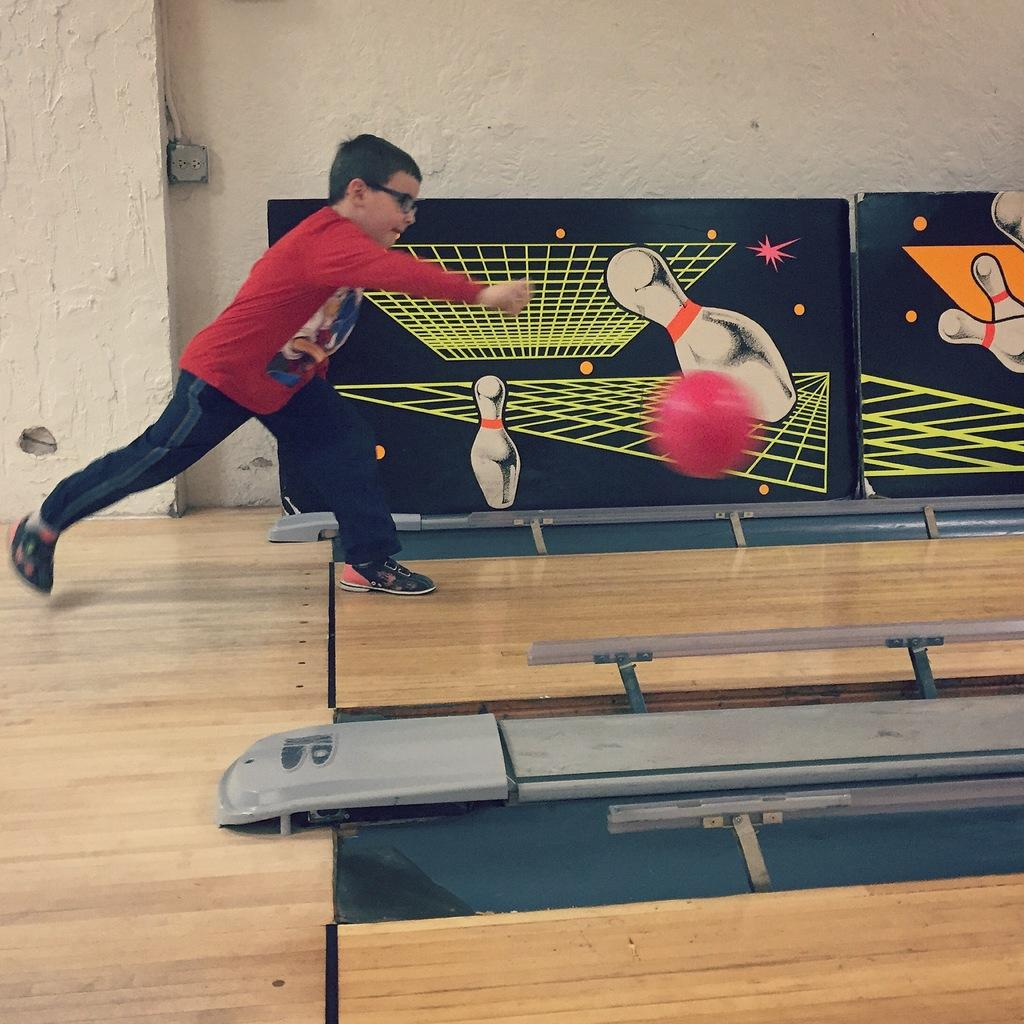What is the main subject of the image? There is a person in the image. What is the person wearing on their upper body? The person is wearing a red shirt. What is the person wearing on their lower body? The person is wearing black pants. What colorful object can be seen in the image? There is a pink ball in the image. What can be seen in the background of the image? There are two black color boards in the background. What color is the wall in the image? The wall is in white color. Where is the zebra hiding in the image? There is no zebra present in the image. What type of stocking is the person wearing in the image? The person is not wearing any stockings in the image. 